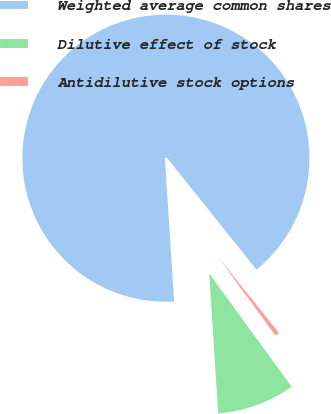Convert chart. <chart><loc_0><loc_0><loc_500><loc_500><pie_chart><fcel>Weighted average common shares<fcel>Dilutive effect of stock<fcel>Antidilutive stock options<nl><fcel>90.27%<fcel>9.0%<fcel>0.73%<nl></chart> 